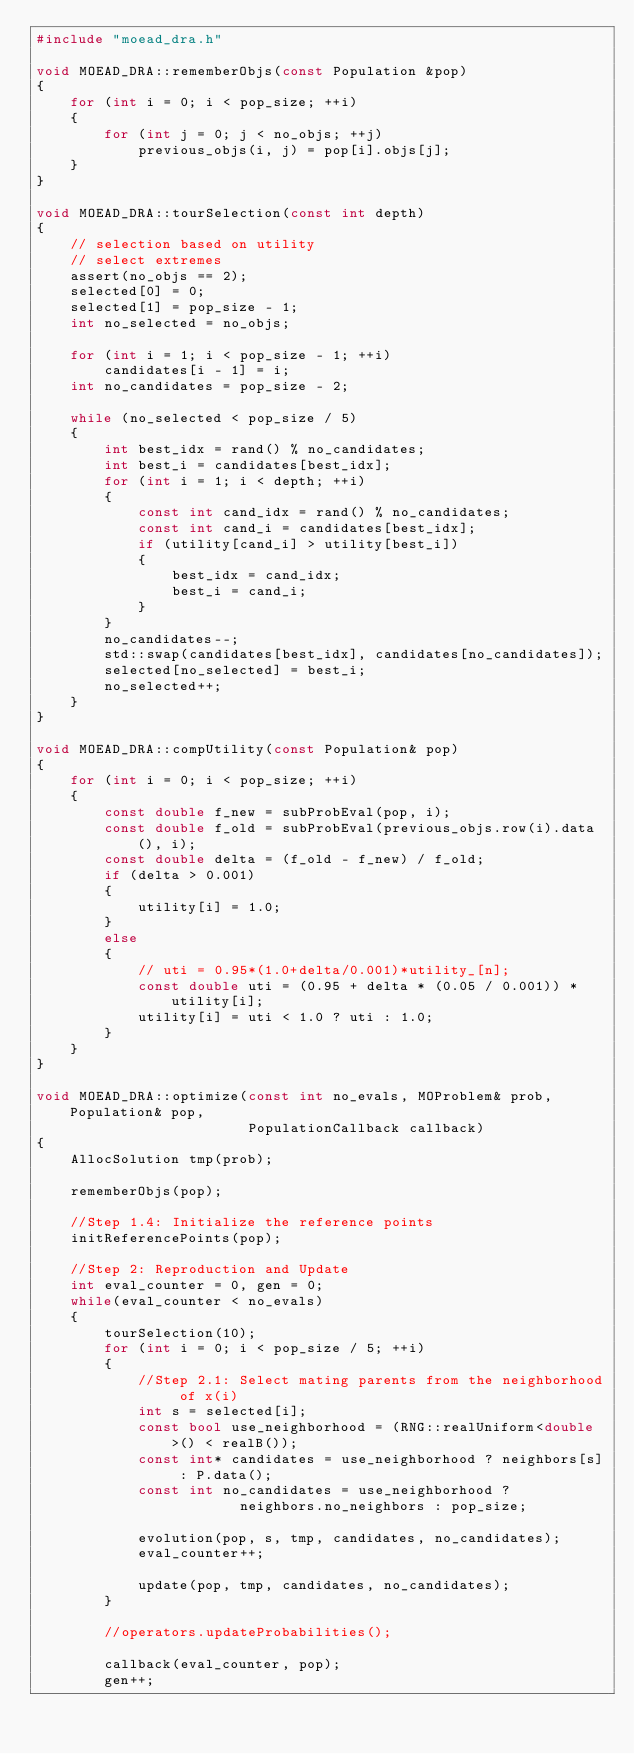Convert code to text. <code><loc_0><loc_0><loc_500><loc_500><_C++_>#include "moead_dra.h"

void MOEAD_DRA::rememberObjs(const Population &pop)
{
    for (int i = 0; i < pop_size; ++i)
    {
        for (int j = 0; j < no_objs; ++j)
            previous_objs(i, j) = pop[i].objs[j];
    }
}

void MOEAD_DRA::tourSelection(const int depth)
{
    // selection based on utility
    // select extremes
    assert(no_objs == 2);
    selected[0] = 0;
    selected[1] = pop_size - 1;
    int no_selected = no_objs;

    for (int i = 1; i < pop_size - 1; ++i)
        candidates[i - 1] = i;
    int no_candidates = pop_size - 2;

    while (no_selected < pop_size / 5)
    {
        int best_idx = rand() % no_candidates;
        int best_i = candidates[best_idx];
        for (int i = 1; i < depth; ++i)
        {
            const int cand_idx = rand() % no_candidates;
            const int cand_i = candidates[best_idx];
            if (utility[cand_i] > utility[best_i])
            {
                best_idx = cand_idx;
                best_i = cand_i;
            }
        }
        no_candidates--;
        std::swap(candidates[best_idx], candidates[no_candidates]);
        selected[no_selected] = best_i;
        no_selected++;
    }
}

void MOEAD_DRA::compUtility(const Population& pop)
{
    for (int i = 0; i < pop_size; ++i)
    {
        const double f_new = subProbEval(pop, i);
        const double f_old = subProbEval(previous_objs.row(i).data(), i);
        const double delta = (f_old - f_new) / f_old;
        if (delta > 0.001)
        {
            utility[i] = 1.0;
        }
        else
        {
            // uti = 0.95*(1.0+delta/0.001)*utility_[n];
            const double uti = (0.95 + delta * (0.05 / 0.001)) * utility[i];
            utility[i] = uti < 1.0 ? uti : 1.0;
        }
    }
}

void MOEAD_DRA::optimize(const int no_evals, MOProblem& prob, Population& pop,
                         PopulationCallback callback)
{
    AllocSolution tmp(prob);

    rememberObjs(pop);

    //Step 1.4: Initialize the reference points
    initReferencePoints(pop);

    //Step 2: Reproduction and Update
    int eval_counter = 0, gen = 0;
    while(eval_counter < no_evals)
    {
        tourSelection(10);
        for (int i = 0; i < pop_size / 5; ++i)
        {
            //Step 2.1: Select mating parents from the neighborhood of x(i)
            int s = selected[i];
            const bool use_neighborhood = (RNG::realUniform<double>() < realB());
            const int* candidates = use_neighborhood ? neighbors[s] : P.data();
            const int no_candidates = use_neighborhood ?
                        neighbors.no_neighbors : pop_size;

            evolution(pop, s, tmp, candidates, no_candidates);
            eval_counter++;

            update(pop, tmp, candidates, no_candidates);
        }

        //operators.updateProbabilities();

        callback(eval_counter, pop);
        gen++;</code> 